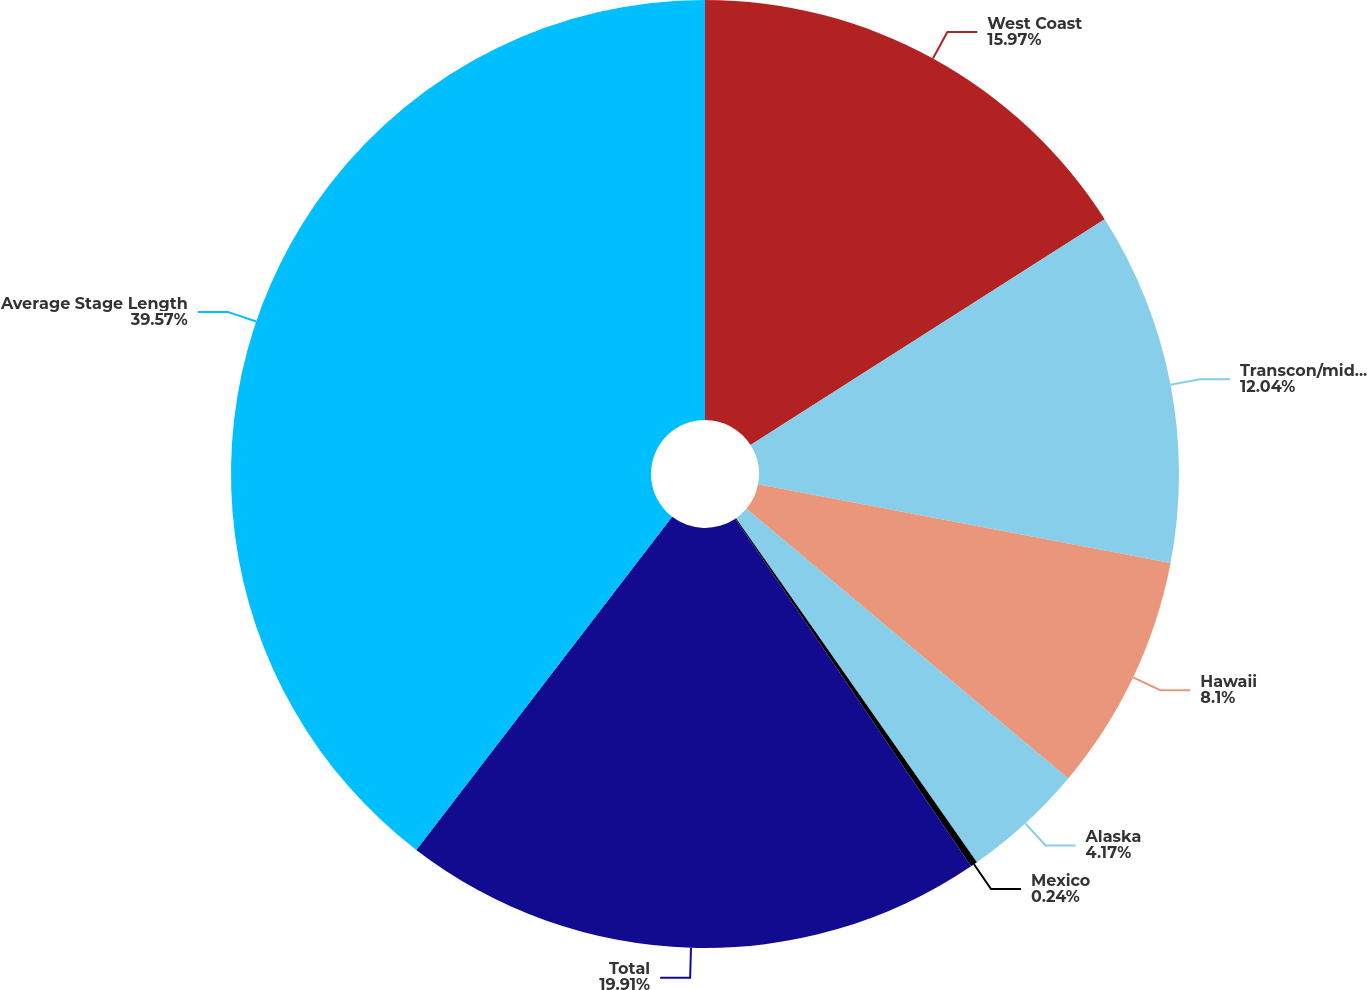Convert chart. <chart><loc_0><loc_0><loc_500><loc_500><pie_chart><fcel>West Coast<fcel>Transcon/midcon<fcel>Hawaii<fcel>Alaska<fcel>Mexico<fcel>Total<fcel>Average Stage Length<nl><fcel>15.97%<fcel>12.04%<fcel>8.1%<fcel>4.17%<fcel>0.24%<fcel>19.91%<fcel>39.58%<nl></chart> 